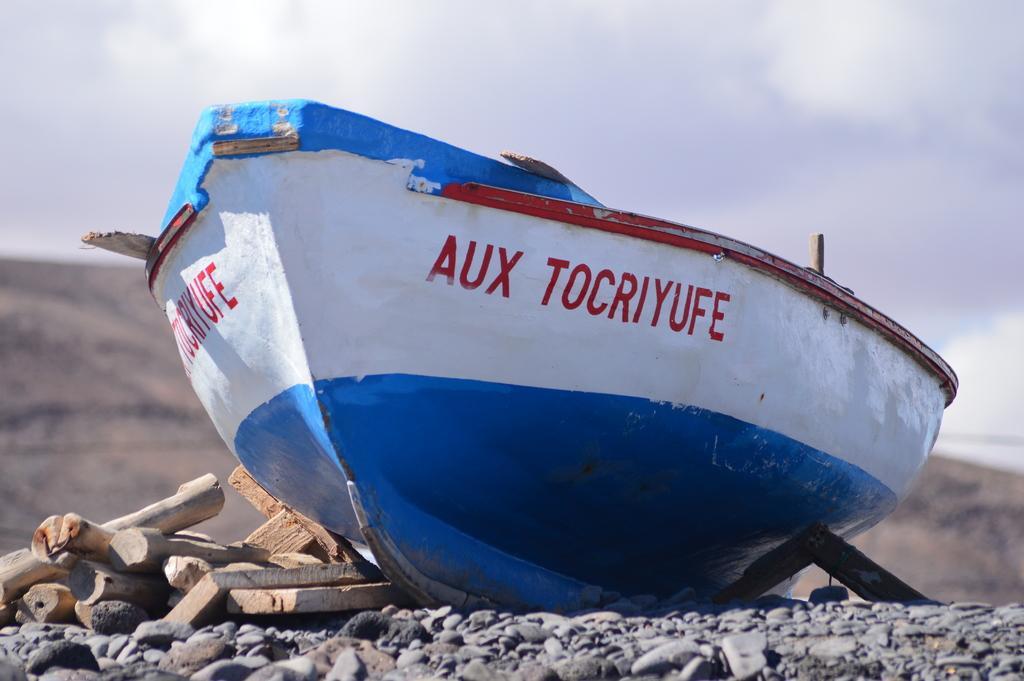How would you summarize this image in a sentence or two? There are wood pieces and stones are present at the bottom of this image. We can see a boat in the middle of this image. The sky is at the top of this image. 